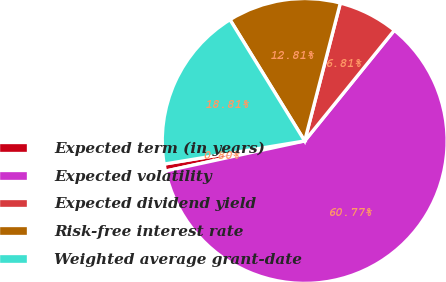Convert chart. <chart><loc_0><loc_0><loc_500><loc_500><pie_chart><fcel>Expected term (in years)<fcel>Expected volatility<fcel>Expected dividend yield<fcel>Risk-free interest rate<fcel>Weighted average grant-date<nl><fcel>0.8%<fcel>60.77%<fcel>6.81%<fcel>12.81%<fcel>18.81%<nl></chart> 